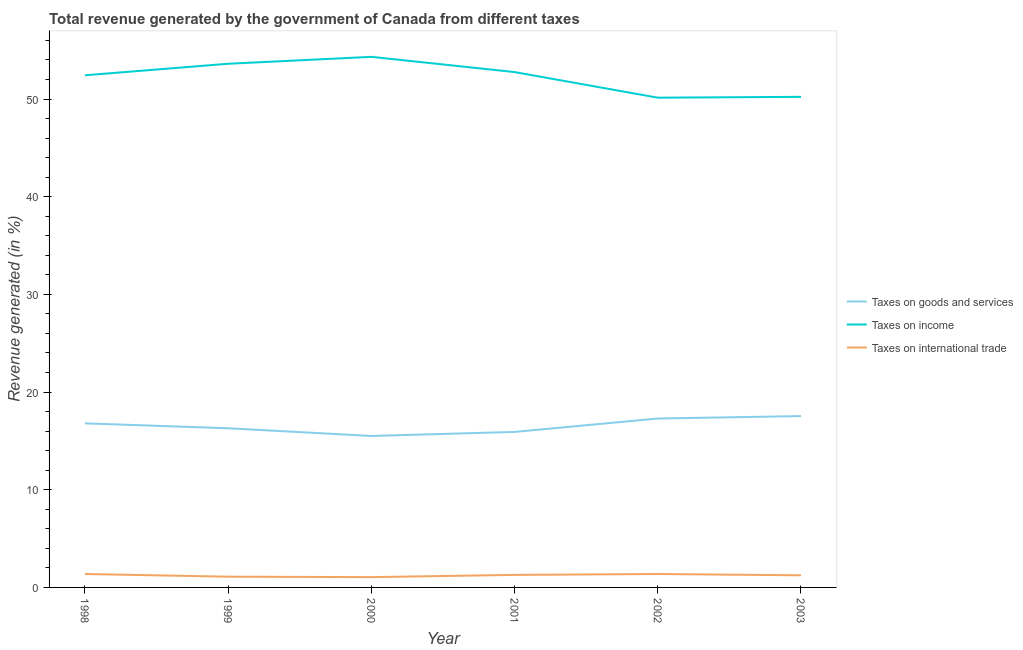Does the line corresponding to percentage of revenue generated by taxes on goods and services intersect with the line corresponding to percentage of revenue generated by taxes on income?
Provide a succinct answer. No. What is the percentage of revenue generated by taxes on goods and services in 1998?
Your answer should be compact. 16.8. Across all years, what is the maximum percentage of revenue generated by tax on international trade?
Provide a succinct answer. 1.37. Across all years, what is the minimum percentage of revenue generated by taxes on income?
Give a very brief answer. 50.14. In which year was the percentage of revenue generated by taxes on income minimum?
Your answer should be very brief. 2002. What is the total percentage of revenue generated by taxes on income in the graph?
Provide a succinct answer. 313.49. What is the difference between the percentage of revenue generated by tax on international trade in 2000 and that in 2002?
Offer a very short reply. -0.32. What is the difference between the percentage of revenue generated by taxes on goods and services in 2001 and the percentage of revenue generated by taxes on income in 1998?
Your answer should be compact. -36.51. What is the average percentage of revenue generated by taxes on goods and services per year?
Offer a very short reply. 16.56. In the year 2003, what is the difference between the percentage of revenue generated by taxes on income and percentage of revenue generated by taxes on goods and services?
Offer a terse response. 32.68. What is the ratio of the percentage of revenue generated by taxes on goods and services in 2000 to that in 2003?
Your response must be concise. 0.88. What is the difference between the highest and the second highest percentage of revenue generated by taxes on goods and services?
Offer a very short reply. 0.25. What is the difference between the highest and the lowest percentage of revenue generated by taxes on income?
Provide a short and direct response. 4.18. Is the sum of the percentage of revenue generated by taxes on income in 1998 and 2003 greater than the maximum percentage of revenue generated by tax on international trade across all years?
Ensure brevity in your answer.  Yes. Are the values on the major ticks of Y-axis written in scientific E-notation?
Offer a very short reply. No. Does the graph contain any zero values?
Give a very brief answer. No. Does the graph contain grids?
Keep it short and to the point. No. Where does the legend appear in the graph?
Give a very brief answer. Center right. How are the legend labels stacked?
Keep it short and to the point. Vertical. What is the title of the graph?
Give a very brief answer. Total revenue generated by the government of Canada from different taxes. Does "Industry" appear as one of the legend labels in the graph?
Ensure brevity in your answer.  No. What is the label or title of the Y-axis?
Your response must be concise. Revenue generated (in %). What is the Revenue generated (in %) of Taxes on goods and services in 1998?
Your answer should be compact. 16.8. What is the Revenue generated (in %) in Taxes on income in 1998?
Your response must be concise. 52.43. What is the Revenue generated (in %) of Taxes on international trade in 1998?
Provide a succinct answer. 1.37. What is the Revenue generated (in %) in Taxes on goods and services in 1999?
Make the answer very short. 16.29. What is the Revenue generated (in %) in Taxes on income in 1999?
Provide a succinct answer. 53.61. What is the Revenue generated (in %) in Taxes on international trade in 1999?
Give a very brief answer. 1.1. What is the Revenue generated (in %) of Taxes on goods and services in 2000?
Give a very brief answer. 15.51. What is the Revenue generated (in %) in Taxes on income in 2000?
Provide a short and direct response. 54.32. What is the Revenue generated (in %) in Taxes on international trade in 2000?
Your answer should be very brief. 1.05. What is the Revenue generated (in %) of Taxes on goods and services in 2001?
Provide a succinct answer. 15.92. What is the Revenue generated (in %) of Taxes on income in 2001?
Keep it short and to the point. 52.76. What is the Revenue generated (in %) in Taxes on international trade in 2001?
Provide a short and direct response. 1.28. What is the Revenue generated (in %) in Taxes on goods and services in 2002?
Your response must be concise. 17.29. What is the Revenue generated (in %) of Taxes on income in 2002?
Your answer should be very brief. 50.14. What is the Revenue generated (in %) in Taxes on international trade in 2002?
Provide a short and direct response. 1.37. What is the Revenue generated (in %) in Taxes on goods and services in 2003?
Ensure brevity in your answer.  17.54. What is the Revenue generated (in %) of Taxes on income in 2003?
Provide a succinct answer. 50.22. What is the Revenue generated (in %) of Taxes on international trade in 2003?
Offer a terse response. 1.24. Across all years, what is the maximum Revenue generated (in %) of Taxes on goods and services?
Offer a terse response. 17.54. Across all years, what is the maximum Revenue generated (in %) in Taxes on income?
Offer a terse response. 54.32. Across all years, what is the maximum Revenue generated (in %) of Taxes on international trade?
Keep it short and to the point. 1.37. Across all years, what is the minimum Revenue generated (in %) of Taxes on goods and services?
Offer a terse response. 15.51. Across all years, what is the minimum Revenue generated (in %) in Taxes on income?
Give a very brief answer. 50.14. Across all years, what is the minimum Revenue generated (in %) of Taxes on international trade?
Your answer should be compact. 1.05. What is the total Revenue generated (in %) in Taxes on goods and services in the graph?
Give a very brief answer. 99.35. What is the total Revenue generated (in %) of Taxes on income in the graph?
Keep it short and to the point. 313.49. What is the total Revenue generated (in %) in Taxes on international trade in the graph?
Your response must be concise. 7.43. What is the difference between the Revenue generated (in %) in Taxes on goods and services in 1998 and that in 1999?
Offer a very short reply. 0.5. What is the difference between the Revenue generated (in %) in Taxes on income in 1998 and that in 1999?
Provide a succinct answer. -1.18. What is the difference between the Revenue generated (in %) of Taxes on international trade in 1998 and that in 1999?
Ensure brevity in your answer.  0.28. What is the difference between the Revenue generated (in %) of Taxes on goods and services in 1998 and that in 2000?
Offer a terse response. 1.29. What is the difference between the Revenue generated (in %) of Taxes on income in 1998 and that in 2000?
Your answer should be very brief. -1.89. What is the difference between the Revenue generated (in %) of Taxes on international trade in 1998 and that in 2000?
Provide a short and direct response. 0.32. What is the difference between the Revenue generated (in %) in Taxes on goods and services in 1998 and that in 2001?
Provide a succinct answer. 0.88. What is the difference between the Revenue generated (in %) in Taxes on income in 1998 and that in 2001?
Your answer should be compact. -0.33. What is the difference between the Revenue generated (in %) in Taxes on international trade in 1998 and that in 2001?
Provide a succinct answer. 0.09. What is the difference between the Revenue generated (in %) in Taxes on goods and services in 1998 and that in 2002?
Your answer should be very brief. -0.49. What is the difference between the Revenue generated (in %) in Taxes on income in 1998 and that in 2002?
Your answer should be compact. 2.29. What is the difference between the Revenue generated (in %) of Taxes on international trade in 1998 and that in 2002?
Provide a succinct answer. 0. What is the difference between the Revenue generated (in %) in Taxes on goods and services in 1998 and that in 2003?
Make the answer very short. -0.74. What is the difference between the Revenue generated (in %) of Taxes on income in 1998 and that in 2003?
Offer a terse response. 2.21. What is the difference between the Revenue generated (in %) of Taxes on international trade in 1998 and that in 2003?
Keep it short and to the point. 0.13. What is the difference between the Revenue generated (in %) in Taxes on goods and services in 1999 and that in 2000?
Provide a short and direct response. 0.79. What is the difference between the Revenue generated (in %) of Taxes on income in 1999 and that in 2000?
Your response must be concise. -0.71. What is the difference between the Revenue generated (in %) in Taxes on international trade in 1999 and that in 2000?
Ensure brevity in your answer.  0.04. What is the difference between the Revenue generated (in %) of Taxes on goods and services in 1999 and that in 2001?
Make the answer very short. 0.37. What is the difference between the Revenue generated (in %) in Taxes on income in 1999 and that in 2001?
Provide a succinct answer. 0.85. What is the difference between the Revenue generated (in %) of Taxes on international trade in 1999 and that in 2001?
Provide a short and direct response. -0.18. What is the difference between the Revenue generated (in %) of Taxes on goods and services in 1999 and that in 2002?
Provide a short and direct response. -1. What is the difference between the Revenue generated (in %) of Taxes on income in 1999 and that in 2002?
Provide a short and direct response. 3.47. What is the difference between the Revenue generated (in %) in Taxes on international trade in 1999 and that in 2002?
Offer a terse response. -0.27. What is the difference between the Revenue generated (in %) in Taxes on goods and services in 1999 and that in 2003?
Keep it short and to the point. -1.25. What is the difference between the Revenue generated (in %) in Taxes on income in 1999 and that in 2003?
Offer a very short reply. 3.39. What is the difference between the Revenue generated (in %) of Taxes on international trade in 1999 and that in 2003?
Ensure brevity in your answer.  -0.14. What is the difference between the Revenue generated (in %) in Taxes on goods and services in 2000 and that in 2001?
Your response must be concise. -0.41. What is the difference between the Revenue generated (in %) in Taxes on income in 2000 and that in 2001?
Your answer should be very brief. 1.56. What is the difference between the Revenue generated (in %) in Taxes on international trade in 2000 and that in 2001?
Ensure brevity in your answer.  -0.23. What is the difference between the Revenue generated (in %) of Taxes on goods and services in 2000 and that in 2002?
Give a very brief answer. -1.79. What is the difference between the Revenue generated (in %) of Taxes on income in 2000 and that in 2002?
Provide a short and direct response. 4.18. What is the difference between the Revenue generated (in %) in Taxes on international trade in 2000 and that in 2002?
Your answer should be very brief. -0.32. What is the difference between the Revenue generated (in %) of Taxes on goods and services in 2000 and that in 2003?
Offer a very short reply. -2.03. What is the difference between the Revenue generated (in %) in Taxes on income in 2000 and that in 2003?
Ensure brevity in your answer.  4.1. What is the difference between the Revenue generated (in %) in Taxes on international trade in 2000 and that in 2003?
Ensure brevity in your answer.  -0.19. What is the difference between the Revenue generated (in %) in Taxes on goods and services in 2001 and that in 2002?
Ensure brevity in your answer.  -1.37. What is the difference between the Revenue generated (in %) of Taxes on income in 2001 and that in 2002?
Ensure brevity in your answer.  2.62. What is the difference between the Revenue generated (in %) in Taxes on international trade in 2001 and that in 2002?
Keep it short and to the point. -0.09. What is the difference between the Revenue generated (in %) of Taxes on goods and services in 2001 and that in 2003?
Your answer should be compact. -1.62. What is the difference between the Revenue generated (in %) in Taxes on income in 2001 and that in 2003?
Your answer should be very brief. 2.54. What is the difference between the Revenue generated (in %) of Taxes on international trade in 2001 and that in 2003?
Your answer should be compact. 0.04. What is the difference between the Revenue generated (in %) of Taxes on goods and services in 2002 and that in 2003?
Ensure brevity in your answer.  -0.25. What is the difference between the Revenue generated (in %) in Taxes on income in 2002 and that in 2003?
Provide a short and direct response. -0.08. What is the difference between the Revenue generated (in %) of Taxes on international trade in 2002 and that in 2003?
Offer a very short reply. 0.13. What is the difference between the Revenue generated (in %) in Taxes on goods and services in 1998 and the Revenue generated (in %) in Taxes on income in 1999?
Your answer should be very brief. -36.81. What is the difference between the Revenue generated (in %) of Taxes on goods and services in 1998 and the Revenue generated (in %) of Taxes on international trade in 1999?
Your answer should be very brief. 15.7. What is the difference between the Revenue generated (in %) in Taxes on income in 1998 and the Revenue generated (in %) in Taxes on international trade in 1999?
Your answer should be compact. 51.33. What is the difference between the Revenue generated (in %) in Taxes on goods and services in 1998 and the Revenue generated (in %) in Taxes on income in 2000?
Your answer should be compact. -37.52. What is the difference between the Revenue generated (in %) of Taxes on goods and services in 1998 and the Revenue generated (in %) of Taxes on international trade in 2000?
Give a very brief answer. 15.74. What is the difference between the Revenue generated (in %) of Taxes on income in 1998 and the Revenue generated (in %) of Taxes on international trade in 2000?
Keep it short and to the point. 51.38. What is the difference between the Revenue generated (in %) in Taxes on goods and services in 1998 and the Revenue generated (in %) in Taxes on income in 2001?
Your answer should be compact. -35.96. What is the difference between the Revenue generated (in %) of Taxes on goods and services in 1998 and the Revenue generated (in %) of Taxes on international trade in 2001?
Give a very brief answer. 15.52. What is the difference between the Revenue generated (in %) of Taxes on income in 1998 and the Revenue generated (in %) of Taxes on international trade in 2001?
Your answer should be compact. 51.15. What is the difference between the Revenue generated (in %) of Taxes on goods and services in 1998 and the Revenue generated (in %) of Taxes on income in 2002?
Ensure brevity in your answer.  -33.34. What is the difference between the Revenue generated (in %) in Taxes on goods and services in 1998 and the Revenue generated (in %) in Taxes on international trade in 2002?
Provide a succinct answer. 15.43. What is the difference between the Revenue generated (in %) in Taxes on income in 1998 and the Revenue generated (in %) in Taxes on international trade in 2002?
Offer a very short reply. 51.06. What is the difference between the Revenue generated (in %) of Taxes on goods and services in 1998 and the Revenue generated (in %) of Taxes on income in 2003?
Provide a succinct answer. -33.43. What is the difference between the Revenue generated (in %) of Taxes on goods and services in 1998 and the Revenue generated (in %) of Taxes on international trade in 2003?
Provide a short and direct response. 15.56. What is the difference between the Revenue generated (in %) in Taxes on income in 1998 and the Revenue generated (in %) in Taxes on international trade in 2003?
Provide a succinct answer. 51.19. What is the difference between the Revenue generated (in %) of Taxes on goods and services in 1999 and the Revenue generated (in %) of Taxes on income in 2000?
Offer a terse response. -38.03. What is the difference between the Revenue generated (in %) in Taxes on goods and services in 1999 and the Revenue generated (in %) in Taxes on international trade in 2000?
Ensure brevity in your answer.  15.24. What is the difference between the Revenue generated (in %) in Taxes on income in 1999 and the Revenue generated (in %) in Taxes on international trade in 2000?
Your answer should be very brief. 52.56. What is the difference between the Revenue generated (in %) of Taxes on goods and services in 1999 and the Revenue generated (in %) of Taxes on income in 2001?
Offer a terse response. -36.47. What is the difference between the Revenue generated (in %) of Taxes on goods and services in 1999 and the Revenue generated (in %) of Taxes on international trade in 2001?
Your answer should be compact. 15.01. What is the difference between the Revenue generated (in %) in Taxes on income in 1999 and the Revenue generated (in %) in Taxes on international trade in 2001?
Give a very brief answer. 52.33. What is the difference between the Revenue generated (in %) of Taxes on goods and services in 1999 and the Revenue generated (in %) of Taxes on income in 2002?
Your answer should be compact. -33.85. What is the difference between the Revenue generated (in %) in Taxes on goods and services in 1999 and the Revenue generated (in %) in Taxes on international trade in 2002?
Provide a short and direct response. 14.92. What is the difference between the Revenue generated (in %) of Taxes on income in 1999 and the Revenue generated (in %) of Taxes on international trade in 2002?
Offer a terse response. 52.24. What is the difference between the Revenue generated (in %) in Taxes on goods and services in 1999 and the Revenue generated (in %) in Taxes on income in 2003?
Ensure brevity in your answer.  -33.93. What is the difference between the Revenue generated (in %) of Taxes on goods and services in 1999 and the Revenue generated (in %) of Taxes on international trade in 2003?
Your response must be concise. 15.05. What is the difference between the Revenue generated (in %) in Taxes on income in 1999 and the Revenue generated (in %) in Taxes on international trade in 2003?
Offer a very short reply. 52.37. What is the difference between the Revenue generated (in %) in Taxes on goods and services in 2000 and the Revenue generated (in %) in Taxes on income in 2001?
Offer a terse response. -37.25. What is the difference between the Revenue generated (in %) in Taxes on goods and services in 2000 and the Revenue generated (in %) in Taxes on international trade in 2001?
Offer a very short reply. 14.22. What is the difference between the Revenue generated (in %) of Taxes on income in 2000 and the Revenue generated (in %) of Taxes on international trade in 2001?
Make the answer very short. 53.04. What is the difference between the Revenue generated (in %) of Taxes on goods and services in 2000 and the Revenue generated (in %) of Taxes on income in 2002?
Offer a terse response. -34.63. What is the difference between the Revenue generated (in %) of Taxes on goods and services in 2000 and the Revenue generated (in %) of Taxes on international trade in 2002?
Make the answer very short. 14.13. What is the difference between the Revenue generated (in %) in Taxes on income in 2000 and the Revenue generated (in %) in Taxes on international trade in 2002?
Provide a short and direct response. 52.95. What is the difference between the Revenue generated (in %) in Taxes on goods and services in 2000 and the Revenue generated (in %) in Taxes on income in 2003?
Keep it short and to the point. -34.72. What is the difference between the Revenue generated (in %) of Taxes on goods and services in 2000 and the Revenue generated (in %) of Taxes on international trade in 2003?
Your response must be concise. 14.26. What is the difference between the Revenue generated (in %) of Taxes on income in 2000 and the Revenue generated (in %) of Taxes on international trade in 2003?
Provide a succinct answer. 53.08. What is the difference between the Revenue generated (in %) in Taxes on goods and services in 2001 and the Revenue generated (in %) in Taxes on income in 2002?
Offer a very short reply. -34.22. What is the difference between the Revenue generated (in %) in Taxes on goods and services in 2001 and the Revenue generated (in %) in Taxes on international trade in 2002?
Give a very brief answer. 14.55. What is the difference between the Revenue generated (in %) of Taxes on income in 2001 and the Revenue generated (in %) of Taxes on international trade in 2002?
Make the answer very short. 51.39. What is the difference between the Revenue generated (in %) in Taxes on goods and services in 2001 and the Revenue generated (in %) in Taxes on income in 2003?
Keep it short and to the point. -34.3. What is the difference between the Revenue generated (in %) in Taxes on goods and services in 2001 and the Revenue generated (in %) in Taxes on international trade in 2003?
Provide a succinct answer. 14.68. What is the difference between the Revenue generated (in %) of Taxes on income in 2001 and the Revenue generated (in %) of Taxes on international trade in 2003?
Offer a terse response. 51.52. What is the difference between the Revenue generated (in %) of Taxes on goods and services in 2002 and the Revenue generated (in %) of Taxes on income in 2003?
Provide a succinct answer. -32.93. What is the difference between the Revenue generated (in %) in Taxes on goods and services in 2002 and the Revenue generated (in %) in Taxes on international trade in 2003?
Keep it short and to the point. 16.05. What is the difference between the Revenue generated (in %) in Taxes on income in 2002 and the Revenue generated (in %) in Taxes on international trade in 2003?
Provide a succinct answer. 48.9. What is the average Revenue generated (in %) in Taxes on goods and services per year?
Keep it short and to the point. 16.56. What is the average Revenue generated (in %) in Taxes on income per year?
Provide a succinct answer. 52.25. What is the average Revenue generated (in %) of Taxes on international trade per year?
Your answer should be compact. 1.24. In the year 1998, what is the difference between the Revenue generated (in %) of Taxes on goods and services and Revenue generated (in %) of Taxes on income?
Your answer should be compact. -35.63. In the year 1998, what is the difference between the Revenue generated (in %) in Taxes on goods and services and Revenue generated (in %) in Taxes on international trade?
Provide a short and direct response. 15.42. In the year 1998, what is the difference between the Revenue generated (in %) of Taxes on income and Revenue generated (in %) of Taxes on international trade?
Give a very brief answer. 51.06. In the year 1999, what is the difference between the Revenue generated (in %) of Taxes on goods and services and Revenue generated (in %) of Taxes on income?
Give a very brief answer. -37.32. In the year 1999, what is the difference between the Revenue generated (in %) in Taxes on goods and services and Revenue generated (in %) in Taxes on international trade?
Provide a short and direct response. 15.2. In the year 1999, what is the difference between the Revenue generated (in %) in Taxes on income and Revenue generated (in %) in Taxes on international trade?
Offer a terse response. 52.51. In the year 2000, what is the difference between the Revenue generated (in %) of Taxes on goods and services and Revenue generated (in %) of Taxes on income?
Your answer should be compact. -38.81. In the year 2000, what is the difference between the Revenue generated (in %) of Taxes on goods and services and Revenue generated (in %) of Taxes on international trade?
Keep it short and to the point. 14.45. In the year 2000, what is the difference between the Revenue generated (in %) in Taxes on income and Revenue generated (in %) in Taxes on international trade?
Give a very brief answer. 53.27. In the year 2001, what is the difference between the Revenue generated (in %) of Taxes on goods and services and Revenue generated (in %) of Taxes on income?
Provide a succinct answer. -36.84. In the year 2001, what is the difference between the Revenue generated (in %) in Taxes on goods and services and Revenue generated (in %) in Taxes on international trade?
Make the answer very short. 14.64. In the year 2001, what is the difference between the Revenue generated (in %) in Taxes on income and Revenue generated (in %) in Taxes on international trade?
Your answer should be compact. 51.48. In the year 2002, what is the difference between the Revenue generated (in %) of Taxes on goods and services and Revenue generated (in %) of Taxes on income?
Make the answer very short. -32.85. In the year 2002, what is the difference between the Revenue generated (in %) of Taxes on goods and services and Revenue generated (in %) of Taxes on international trade?
Your answer should be very brief. 15.92. In the year 2002, what is the difference between the Revenue generated (in %) of Taxes on income and Revenue generated (in %) of Taxes on international trade?
Make the answer very short. 48.77. In the year 2003, what is the difference between the Revenue generated (in %) in Taxes on goods and services and Revenue generated (in %) in Taxes on income?
Offer a very short reply. -32.68. In the year 2003, what is the difference between the Revenue generated (in %) in Taxes on goods and services and Revenue generated (in %) in Taxes on international trade?
Ensure brevity in your answer.  16.3. In the year 2003, what is the difference between the Revenue generated (in %) in Taxes on income and Revenue generated (in %) in Taxes on international trade?
Your answer should be compact. 48.98. What is the ratio of the Revenue generated (in %) of Taxes on goods and services in 1998 to that in 1999?
Offer a very short reply. 1.03. What is the ratio of the Revenue generated (in %) of Taxes on income in 1998 to that in 1999?
Give a very brief answer. 0.98. What is the ratio of the Revenue generated (in %) in Taxes on international trade in 1998 to that in 1999?
Your answer should be compact. 1.25. What is the ratio of the Revenue generated (in %) of Taxes on income in 1998 to that in 2000?
Make the answer very short. 0.97. What is the ratio of the Revenue generated (in %) in Taxes on international trade in 1998 to that in 2000?
Offer a terse response. 1.3. What is the ratio of the Revenue generated (in %) of Taxes on goods and services in 1998 to that in 2001?
Your response must be concise. 1.06. What is the ratio of the Revenue generated (in %) of Taxes on international trade in 1998 to that in 2001?
Your response must be concise. 1.07. What is the ratio of the Revenue generated (in %) in Taxes on goods and services in 1998 to that in 2002?
Offer a very short reply. 0.97. What is the ratio of the Revenue generated (in %) in Taxes on income in 1998 to that in 2002?
Make the answer very short. 1.05. What is the ratio of the Revenue generated (in %) in Taxes on international trade in 1998 to that in 2002?
Offer a very short reply. 1. What is the ratio of the Revenue generated (in %) of Taxes on goods and services in 1998 to that in 2003?
Give a very brief answer. 0.96. What is the ratio of the Revenue generated (in %) in Taxes on income in 1998 to that in 2003?
Your response must be concise. 1.04. What is the ratio of the Revenue generated (in %) in Taxes on international trade in 1998 to that in 2003?
Offer a very short reply. 1.11. What is the ratio of the Revenue generated (in %) in Taxes on goods and services in 1999 to that in 2000?
Offer a terse response. 1.05. What is the ratio of the Revenue generated (in %) in Taxes on income in 1999 to that in 2000?
Keep it short and to the point. 0.99. What is the ratio of the Revenue generated (in %) in Taxes on international trade in 1999 to that in 2000?
Your response must be concise. 1.04. What is the ratio of the Revenue generated (in %) of Taxes on goods and services in 1999 to that in 2001?
Your answer should be very brief. 1.02. What is the ratio of the Revenue generated (in %) of Taxes on income in 1999 to that in 2001?
Your response must be concise. 1.02. What is the ratio of the Revenue generated (in %) in Taxes on international trade in 1999 to that in 2001?
Your answer should be very brief. 0.86. What is the ratio of the Revenue generated (in %) in Taxes on goods and services in 1999 to that in 2002?
Your answer should be very brief. 0.94. What is the ratio of the Revenue generated (in %) in Taxes on income in 1999 to that in 2002?
Your answer should be very brief. 1.07. What is the ratio of the Revenue generated (in %) of Taxes on international trade in 1999 to that in 2002?
Offer a terse response. 0.8. What is the ratio of the Revenue generated (in %) of Taxes on goods and services in 1999 to that in 2003?
Provide a short and direct response. 0.93. What is the ratio of the Revenue generated (in %) of Taxes on income in 1999 to that in 2003?
Your answer should be compact. 1.07. What is the ratio of the Revenue generated (in %) of Taxes on international trade in 1999 to that in 2003?
Ensure brevity in your answer.  0.88. What is the ratio of the Revenue generated (in %) in Taxes on goods and services in 2000 to that in 2001?
Your answer should be compact. 0.97. What is the ratio of the Revenue generated (in %) in Taxes on income in 2000 to that in 2001?
Give a very brief answer. 1.03. What is the ratio of the Revenue generated (in %) in Taxes on international trade in 2000 to that in 2001?
Offer a terse response. 0.82. What is the ratio of the Revenue generated (in %) in Taxes on goods and services in 2000 to that in 2002?
Your answer should be very brief. 0.9. What is the ratio of the Revenue generated (in %) in Taxes on income in 2000 to that in 2002?
Keep it short and to the point. 1.08. What is the ratio of the Revenue generated (in %) in Taxes on international trade in 2000 to that in 2002?
Ensure brevity in your answer.  0.77. What is the ratio of the Revenue generated (in %) of Taxes on goods and services in 2000 to that in 2003?
Give a very brief answer. 0.88. What is the ratio of the Revenue generated (in %) in Taxes on income in 2000 to that in 2003?
Your answer should be very brief. 1.08. What is the ratio of the Revenue generated (in %) of Taxes on international trade in 2000 to that in 2003?
Give a very brief answer. 0.85. What is the ratio of the Revenue generated (in %) of Taxes on goods and services in 2001 to that in 2002?
Keep it short and to the point. 0.92. What is the ratio of the Revenue generated (in %) in Taxes on income in 2001 to that in 2002?
Your answer should be very brief. 1.05. What is the ratio of the Revenue generated (in %) in Taxes on international trade in 2001 to that in 2002?
Provide a succinct answer. 0.93. What is the ratio of the Revenue generated (in %) in Taxes on goods and services in 2001 to that in 2003?
Provide a succinct answer. 0.91. What is the ratio of the Revenue generated (in %) of Taxes on income in 2001 to that in 2003?
Your response must be concise. 1.05. What is the ratio of the Revenue generated (in %) of Taxes on international trade in 2001 to that in 2003?
Your response must be concise. 1.03. What is the ratio of the Revenue generated (in %) of Taxes on goods and services in 2002 to that in 2003?
Keep it short and to the point. 0.99. What is the ratio of the Revenue generated (in %) of Taxes on international trade in 2002 to that in 2003?
Your answer should be compact. 1.11. What is the difference between the highest and the second highest Revenue generated (in %) of Taxes on goods and services?
Make the answer very short. 0.25. What is the difference between the highest and the second highest Revenue generated (in %) in Taxes on income?
Offer a very short reply. 0.71. What is the difference between the highest and the second highest Revenue generated (in %) in Taxes on international trade?
Your response must be concise. 0. What is the difference between the highest and the lowest Revenue generated (in %) in Taxes on goods and services?
Your answer should be very brief. 2.03. What is the difference between the highest and the lowest Revenue generated (in %) in Taxes on income?
Offer a terse response. 4.18. What is the difference between the highest and the lowest Revenue generated (in %) of Taxes on international trade?
Provide a short and direct response. 0.32. 